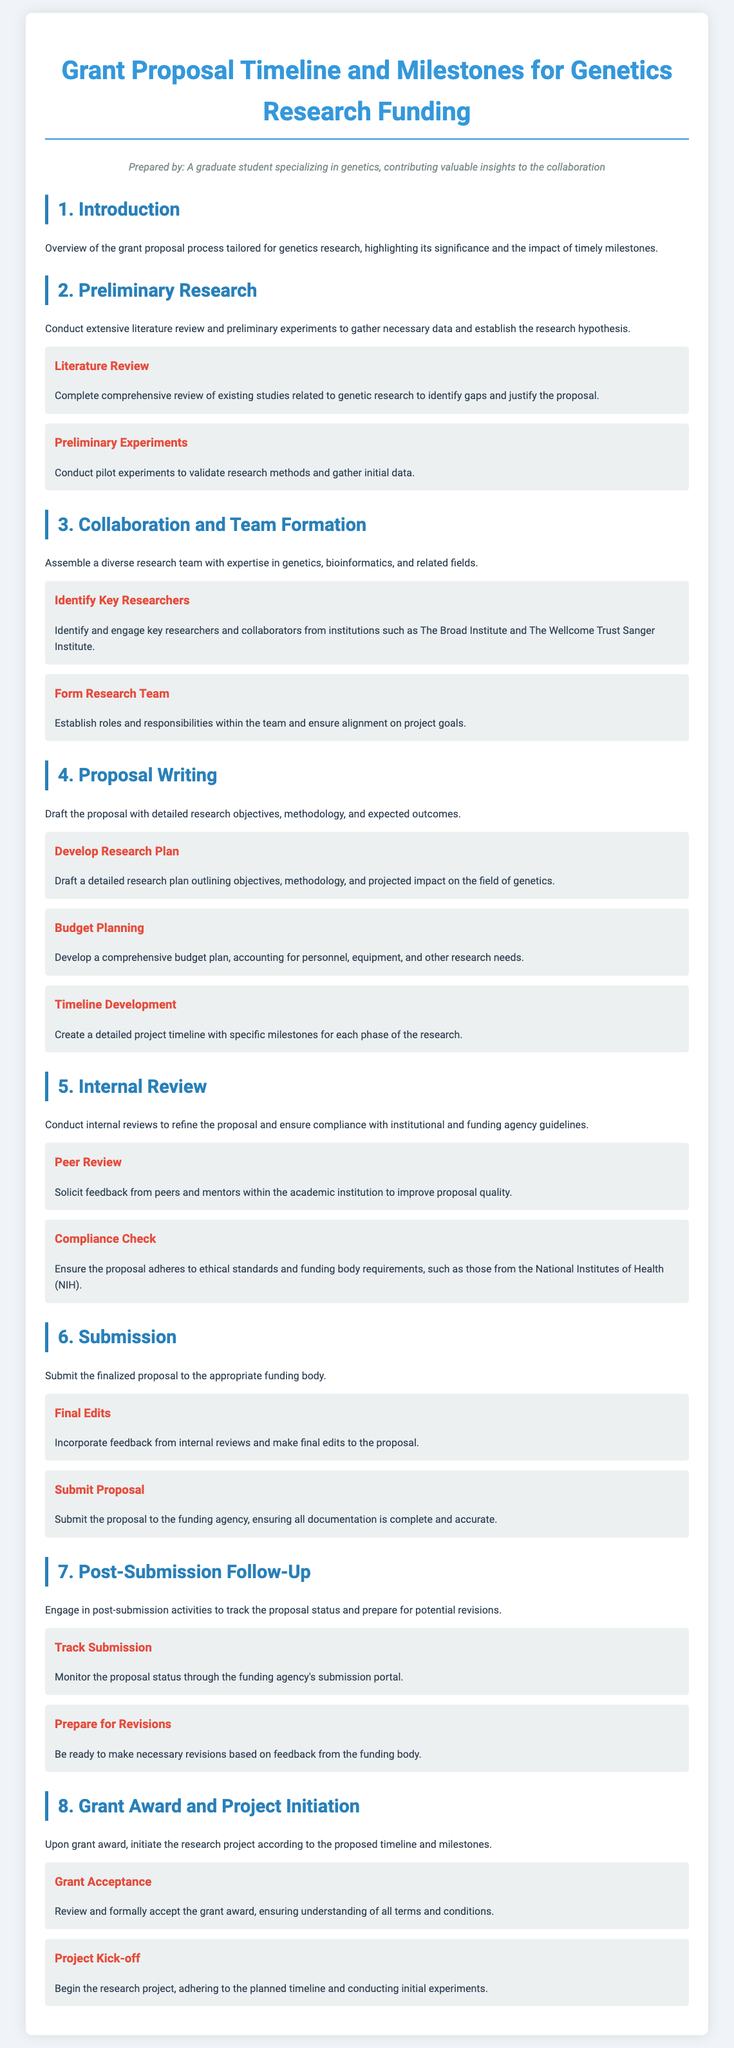What is the main focus of the grant proposal? The main focus of the grant proposal is tailored for genetics research, highlighting its significance and the impact of timely milestones.
Answer: genetics research What is the first milestone in the Preliminary Research section? The first milestone is to complete a comprehensive review of existing studies related to genetic research to identify gaps and justify the proposal.
Answer: Literature Review Who should be identified in the Collaboration and Team Formation section? Key researchers and collaborators from institutions such as The Broad Institute and The Wellcome Trust Sanger Institute should be identified.
Answer: Key Researchers What is developed in the Proposal Writing section to account for research needs? A comprehensive budget plan is developed to account for personnel, equipment, and other research needs.
Answer: Budget Planning How many milestones are in the Submission section? The Submission section contains two milestones.
Answer: 2 What is the purpose of the Post-Submission Follow-Up section? The purpose is to engage in post-submission activities to track the proposal status and prepare for potential revisions.
Answer: track the proposal status What does grant acceptance involve? Grant acceptance involves reviewing and formally accepting the grant award, ensuring understanding of all terms and conditions.
Answer: Grant Acceptance What is initiated upon grant award according to the document? The research project is initiated according to the proposed timeline and milestones upon grant award.
Answer: research project 